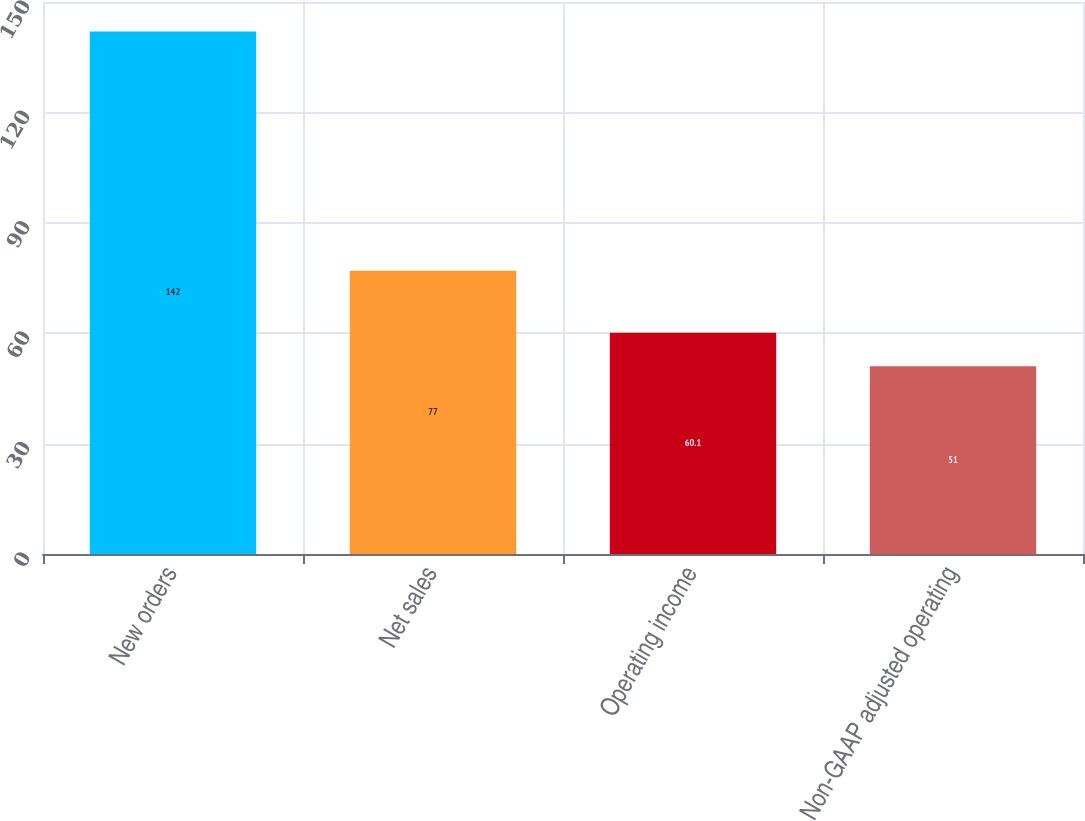Convert chart. <chart><loc_0><loc_0><loc_500><loc_500><bar_chart><fcel>New orders<fcel>Net sales<fcel>Operating income<fcel>Non-GAAP adjusted operating<nl><fcel>142<fcel>77<fcel>60.1<fcel>51<nl></chart> 